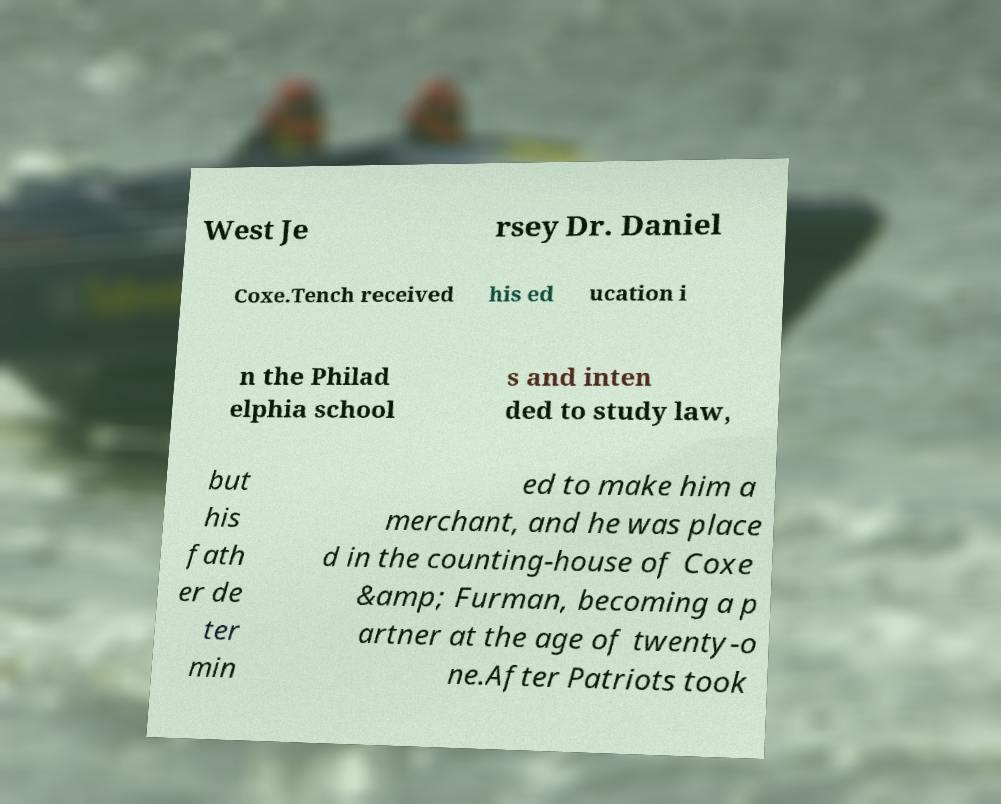Could you assist in decoding the text presented in this image and type it out clearly? West Je rsey Dr. Daniel Coxe.Tench received his ed ucation i n the Philad elphia school s and inten ded to study law, but his fath er de ter min ed to make him a merchant, and he was place d in the counting-house of Coxe &amp; Furman, becoming a p artner at the age of twenty-o ne.After Patriots took 